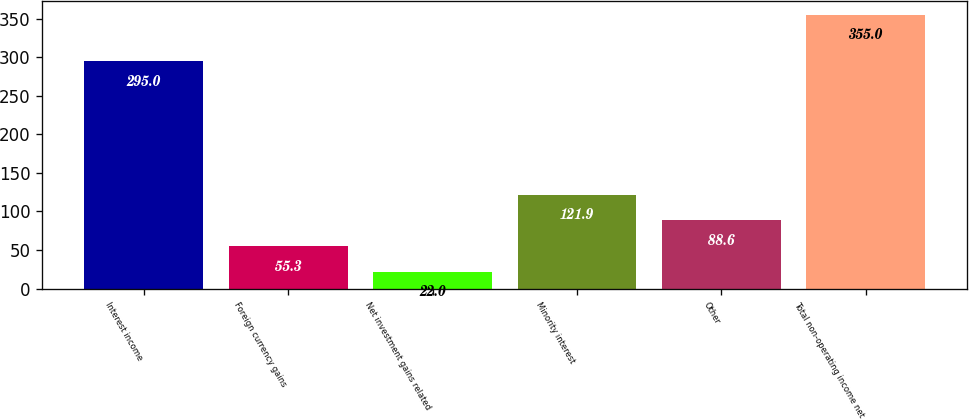Convert chart to OTSL. <chart><loc_0><loc_0><loc_500><loc_500><bar_chart><fcel>Interest income<fcel>Foreign currency gains<fcel>Net investment gains related<fcel>Minority interest<fcel>Other<fcel>Total non-operating income net<nl><fcel>295<fcel>55.3<fcel>22<fcel>121.9<fcel>88.6<fcel>355<nl></chart> 